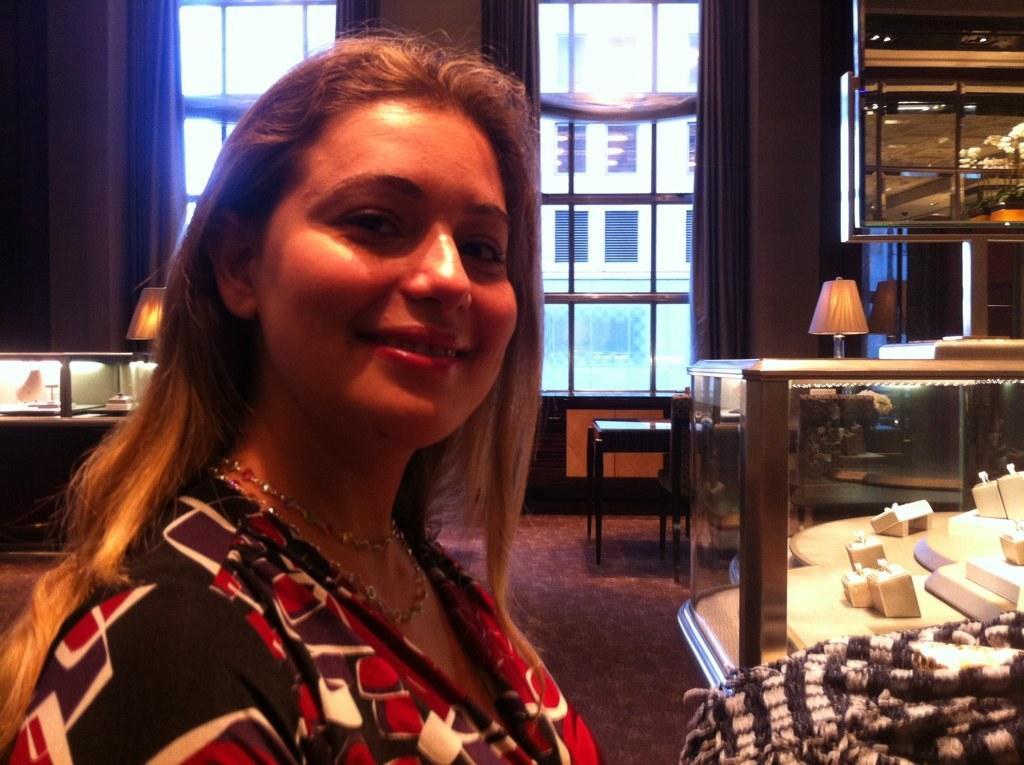Please provide a concise description of this image. In this image we can see a woman is smiling and on the right side there are objects placed in a glass box and a cloth. In the background there are windows, curtains, wall, lamps, floor and objects. Through the window glasses we can see building and windows. 